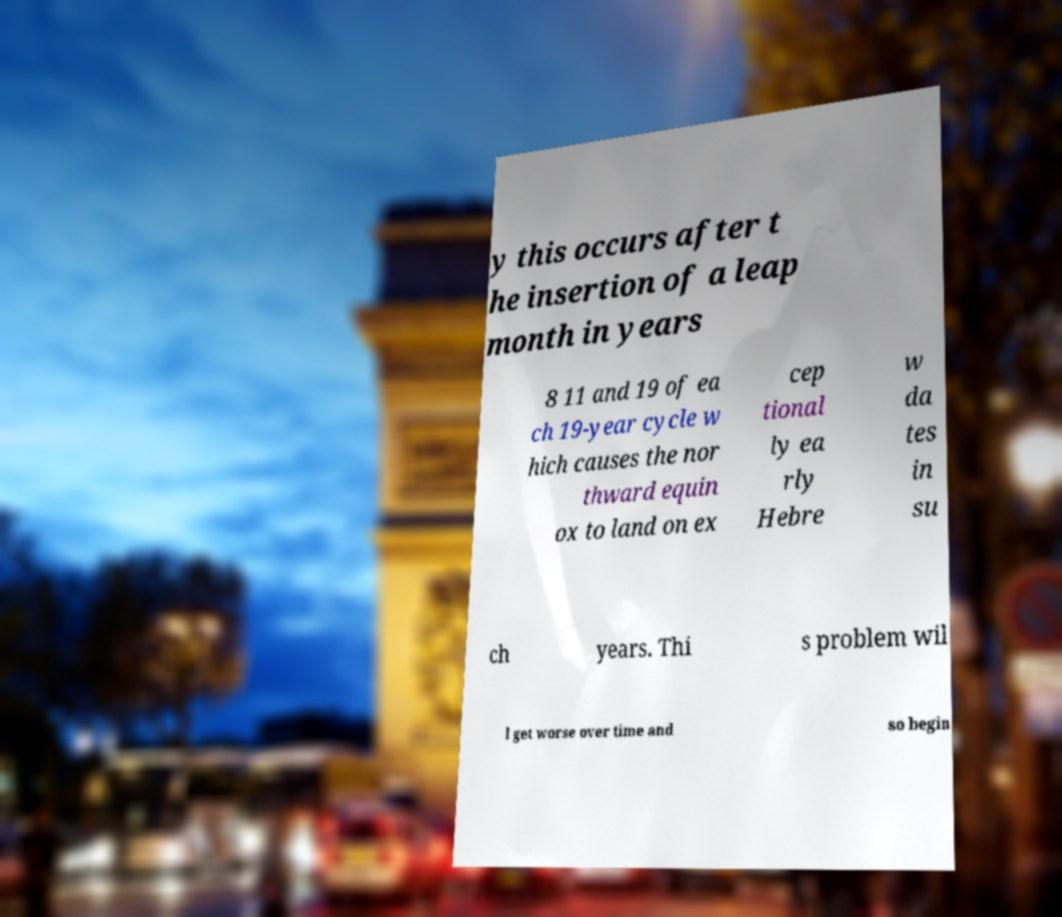I need the written content from this picture converted into text. Can you do that? y this occurs after t he insertion of a leap month in years 8 11 and 19 of ea ch 19-year cycle w hich causes the nor thward equin ox to land on ex cep tional ly ea rly Hebre w da tes in su ch years. Thi s problem wil l get worse over time and so begin 